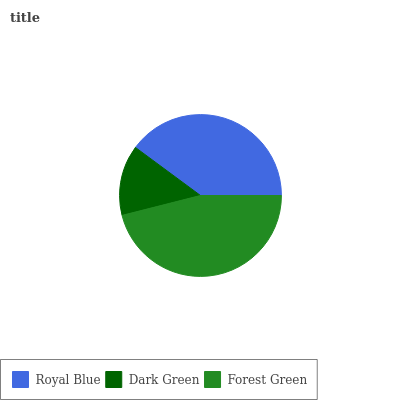Is Dark Green the minimum?
Answer yes or no. Yes. Is Forest Green the maximum?
Answer yes or no. Yes. Is Forest Green the minimum?
Answer yes or no. No. Is Dark Green the maximum?
Answer yes or no. No. Is Forest Green greater than Dark Green?
Answer yes or no. Yes. Is Dark Green less than Forest Green?
Answer yes or no. Yes. Is Dark Green greater than Forest Green?
Answer yes or no. No. Is Forest Green less than Dark Green?
Answer yes or no. No. Is Royal Blue the high median?
Answer yes or no. Yes. Is Royal Blue the low median?
Answer yes or no. Yes. Is Forest Green the high median?
Answer yes or no. No. Is Forest Green the low median?
Answer yes or no. No. 